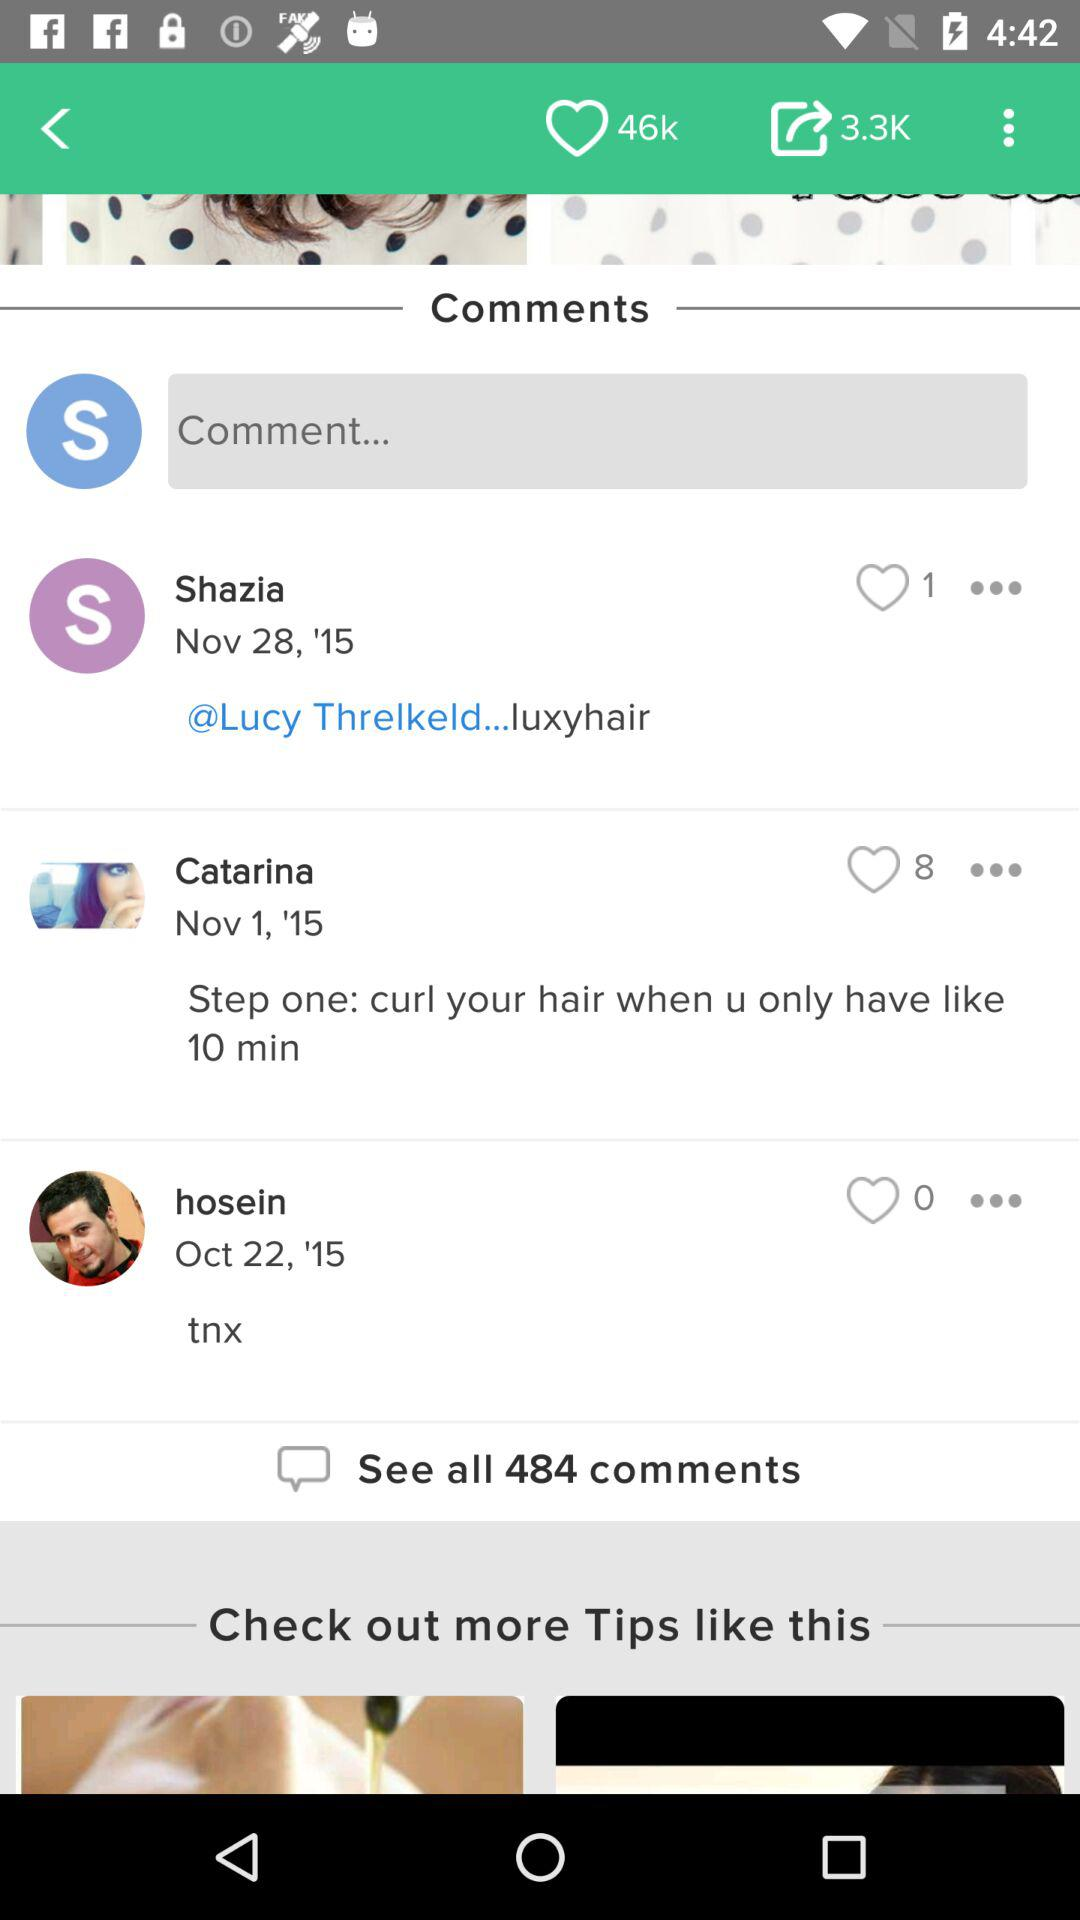How many comments are there on this post?
Answer the question using a single word or phrase. 484 